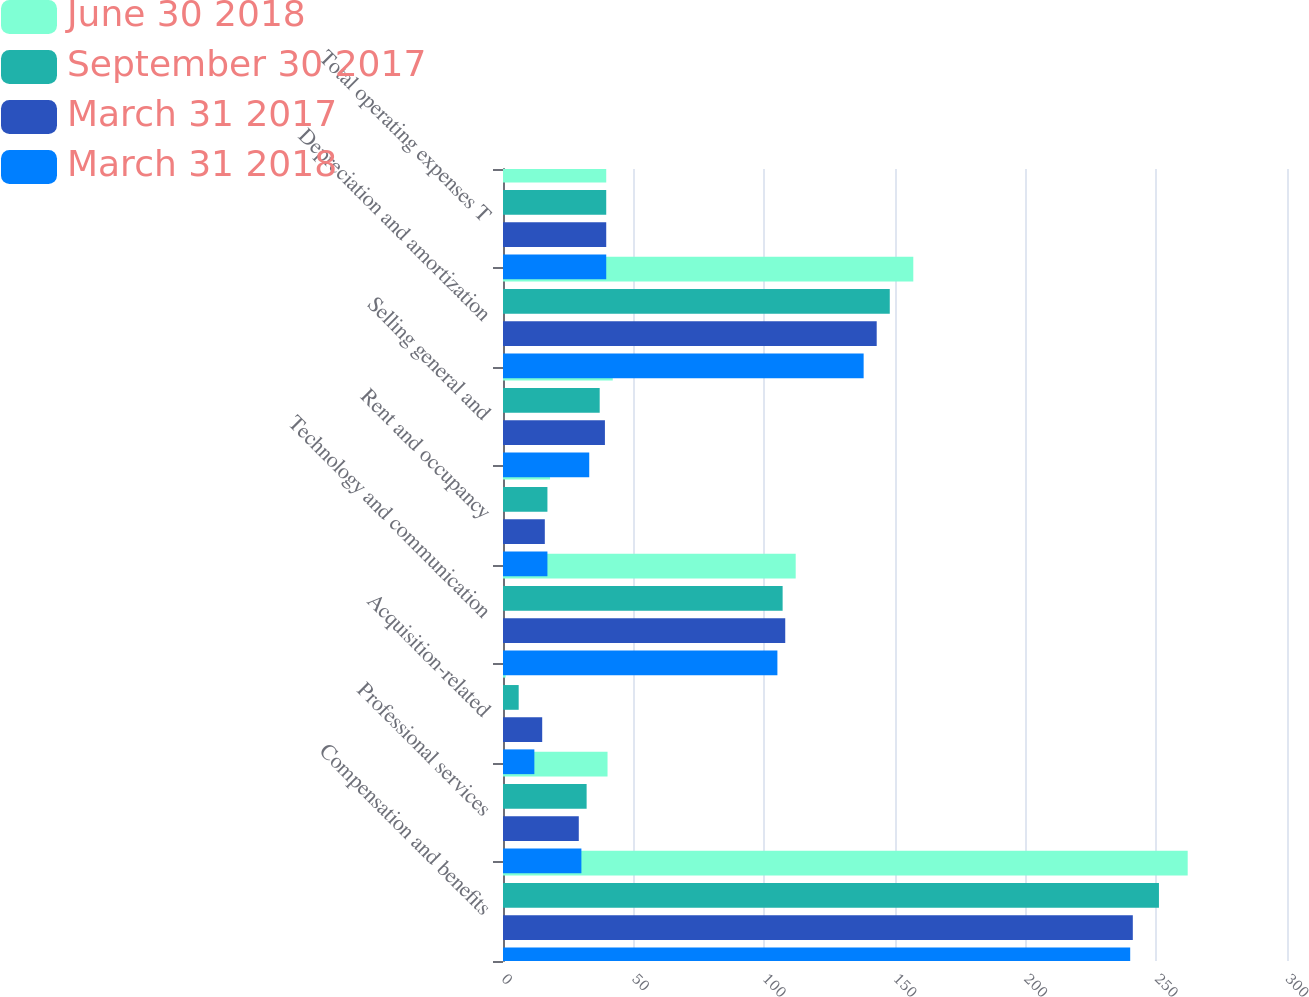Convert chart to OTSL. <chart><loc_0><loc_0><loc_500><loc_500><stacked_bar_chart><ecel><fcel>Compensation and benefits<fcel>Professional services<fcel>Acquisition-related<fcel>Technology and communication<fcel>Rent and occupancy<fcel>Selling general and<fcel>Depreciation and amortization<fcel>Total operating expenses T<nl><fcel>June 30 2018<fcel>262<fcel>40<fcel>1<fcel>112<fcel>18<fcel>42<fcel>157<fcel>39.5<nl><fcel>September 30 2017<fcel>251<fcel>32<fcel>6<fcel>107<fcel>17<fcel>37<fcel>148<fcel>39.5<nl><fcel>March 31 2017<fcel>241<fcel>29<fcel>15<fcel>108<fcel>16<fcel>39<fcel>143<fcel>39.5<nl><fcel>March 31 2018<fcel>240<fcel>30<fcel>12<fcel>105<fcel>17<fcel>33<fcel>138<fcel>39.5<nl></chart> 